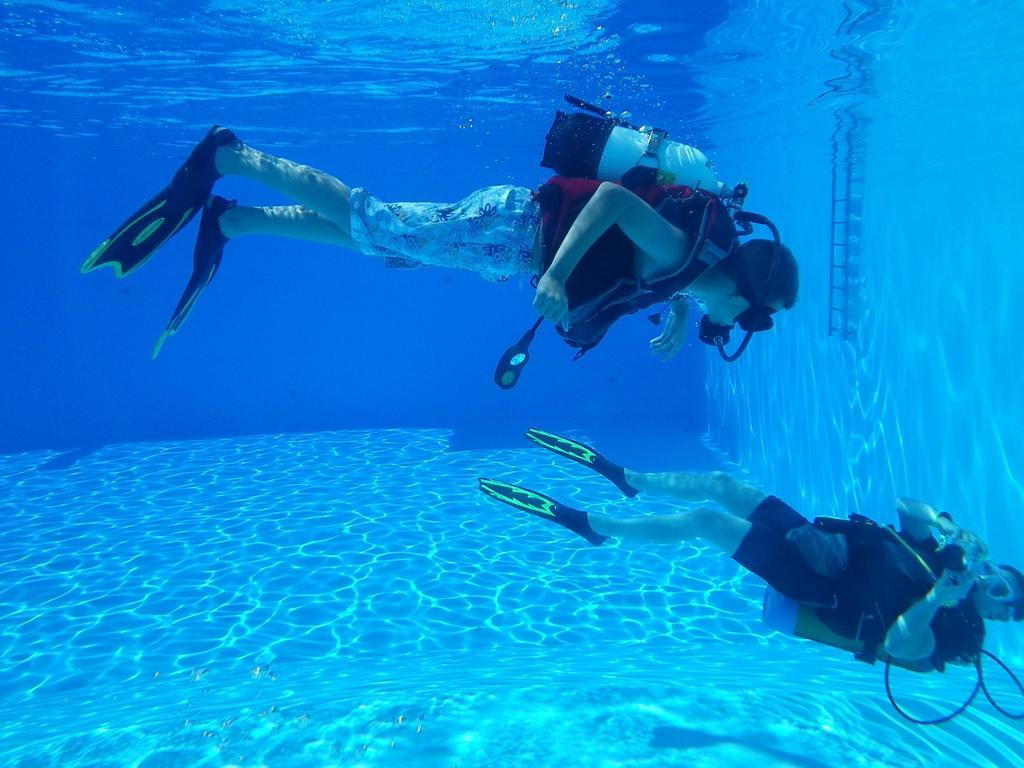How many people are in the image? There are two persons in the image. What are the two persons doing in the image? The two persons are diving inside the water. How many kittens are playing on the bed in the image? There are no kittens or beds present in the image; it features two persons diving inside the water. 